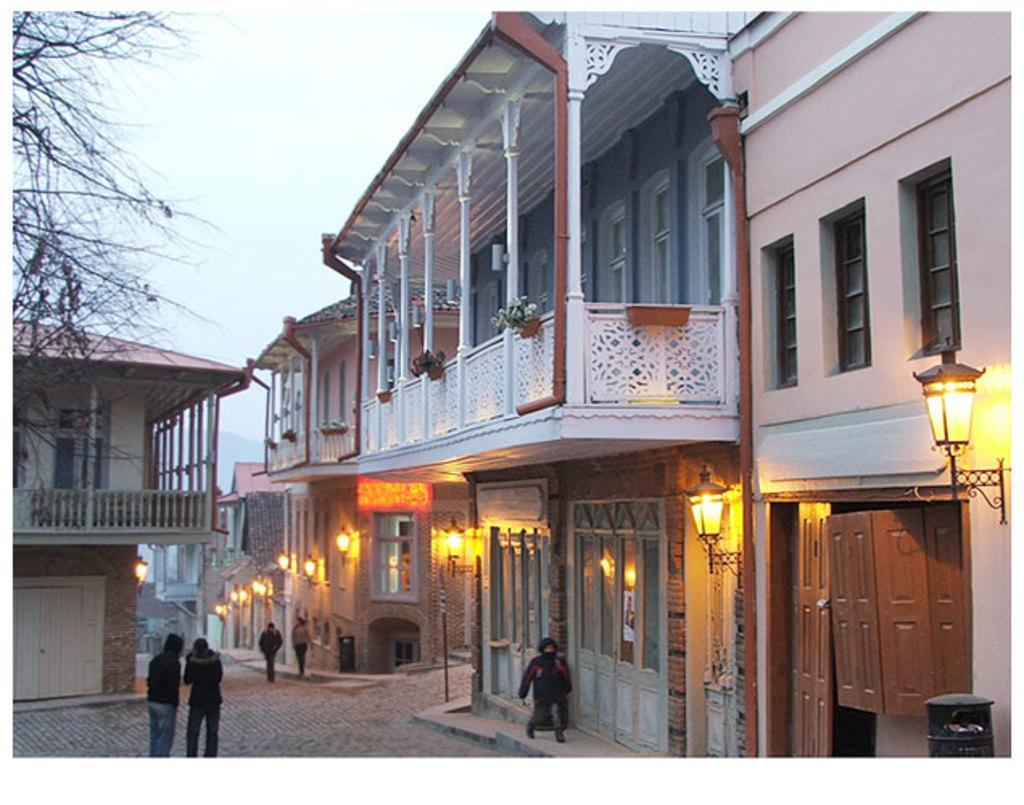Can you describe this image briefly? In this picture I can see few persons in the middle, there are buildings and lights on either side of this image. On the left side there are trees, at the top I can see the sky. 